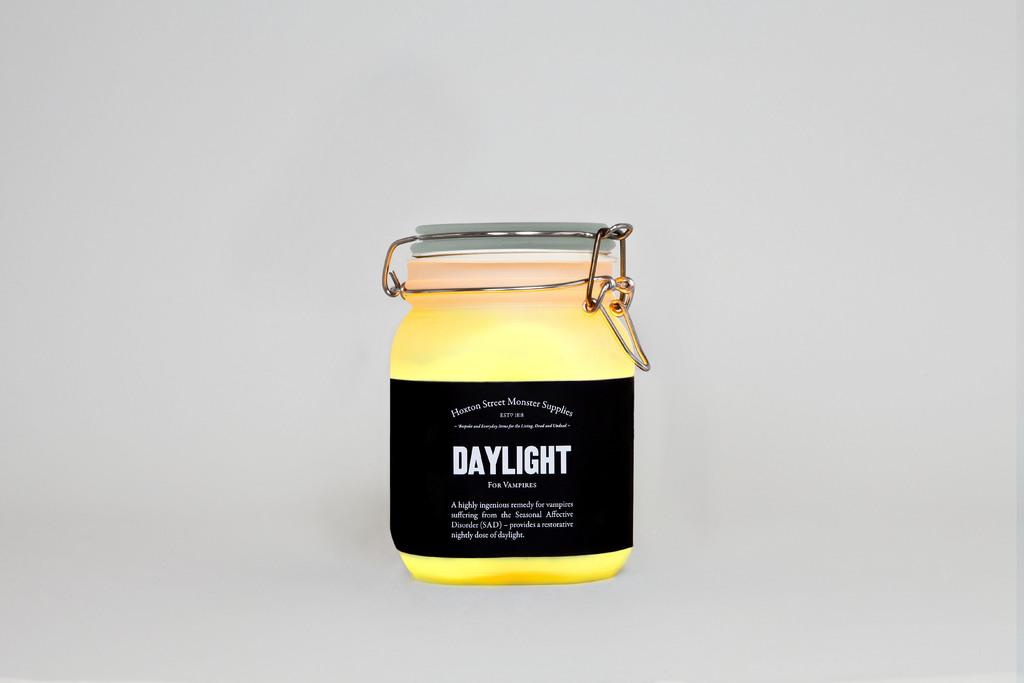<image>
Create a compact narrative representing the image presented. A jar with the word DAYLIGHT in big bold letters printed upon its side. 